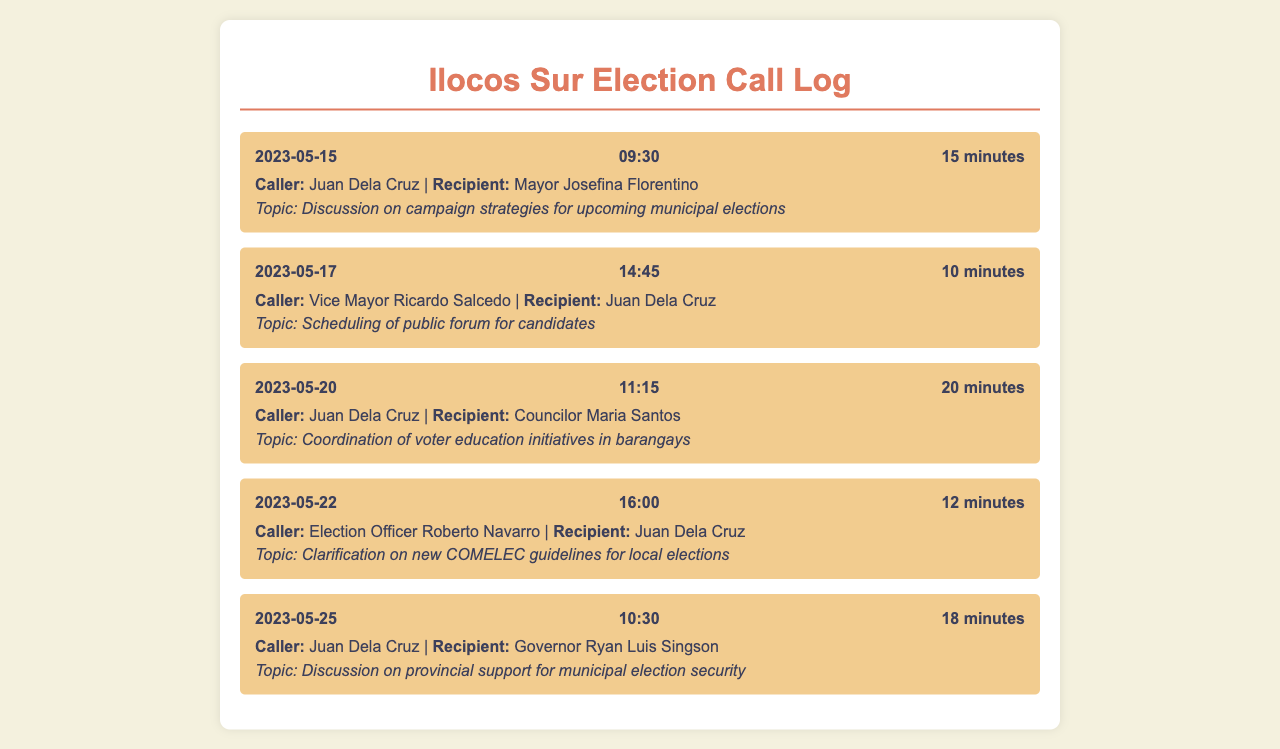What is the date of the call regarding campaign strategies? The date is specifically noted in the document as the day the call occurred, which is May 15, 2023.
Answer: May 15, 2023 Who was the recipient of the call on May 20, 2023? The document indicates that Juan Dela Cruz was calling Councilor Maria Santos.
Answer: Councilor Maria Santos What was discussed in the call on May 25, 2023? The topic of this call was about provincial support for municipal election security, mentioned in the call entry.
Answer: Provincial support for municipal election security How long was the call made by Vice Mayor Ricardo Salcedo? The duration of the call is specifically stated in the call entry, which is 10 minutes.
Answer: 10 minutes Who initiated the call on May 22, 2023? The document identifies the caller as Election Officer Roberto Navarro in the pertinent call entry.
Answer: Election Officer Roberto Navarro How many minutes did the call concerning voter education initiatives last? The document states that the duration of the call was 20 minutes, specifically detailing the time spent.
Answer: 20 minutes What was the call topic discussed between Juan Dela Cruz and Mayor Josefina Florentino? The discussion topic was about campaign strategies for upcoming municipal elections, as per the call entry information.
Answer: Campaign strategies for upcoming municipal elections 